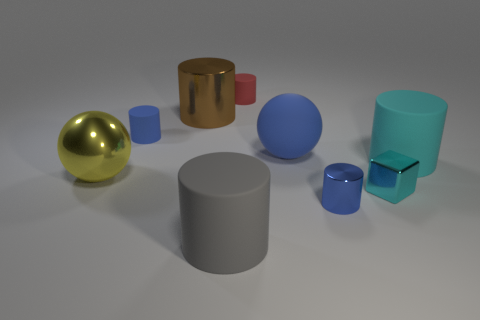Are there fewer big gray rubber things than gray matte balls?
Your answer should be compact. No. How many large cyan cylinders have the same material as the large gray object?
Keep it short and to the point. 1. There is another large thing that is the same material as the big yellow object; what is its color?
Ensure brevity in your answer.  Brown. There is a big brown metallic object; what shape is it?
Your answer should be compact. Cylinder. What number of small blocks are the same color as the large matte sphere?
Ensure brevity in your answer.  0. The red matte thing that is the same size as the blue metallic cylinder is what shape?
Make the answer very short. Cylinder. Is there a blue rubber ball of the same size as the brown thing?
Provide a succinct answer. Yes. There is a red object that is the same size as the cyan shiny cube; what is its material?
Your answer should be very brief. Rubber. What is the size of the sphere that is left of the big rubber thing in front of the tiny shiny cube?
Ensure brevity in your answer.  Large. There is a brown metal object on the left side of the cyan cylinder; does it have the same size as the tiny blue matte object?
Provide a short and direct response. No. 